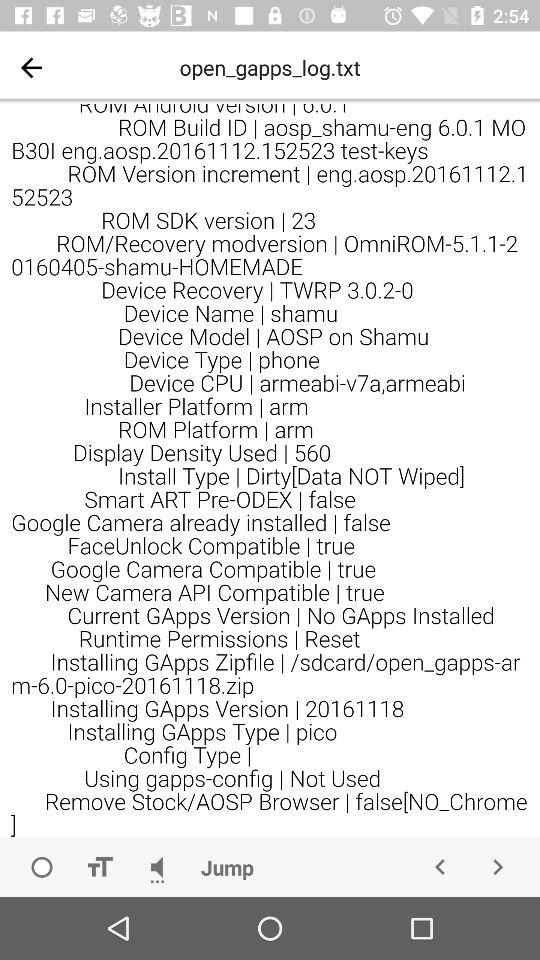What is the "Display Density Used"? The "Display Density Used" is 560. 